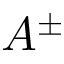Convert formula to latex. <formula><loc_0><loc_0><loc_500><loc_500>A ^ { \pm }</formula> 